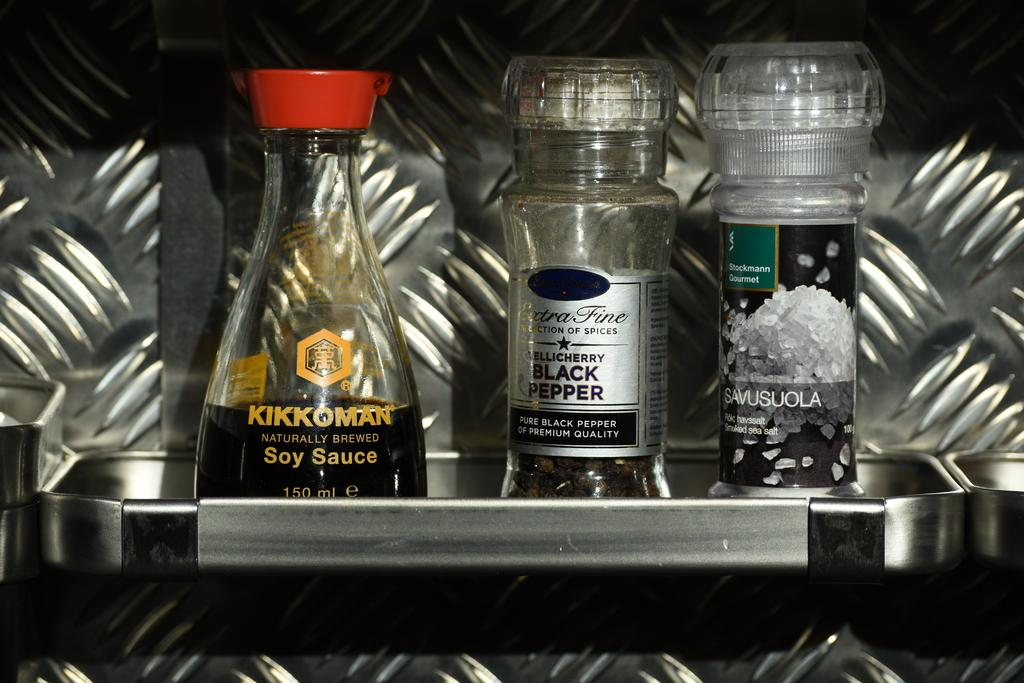<image>
Give a short and clear explanation of the subsequent image. The soy sauce shown to the left is naturally sourced. 